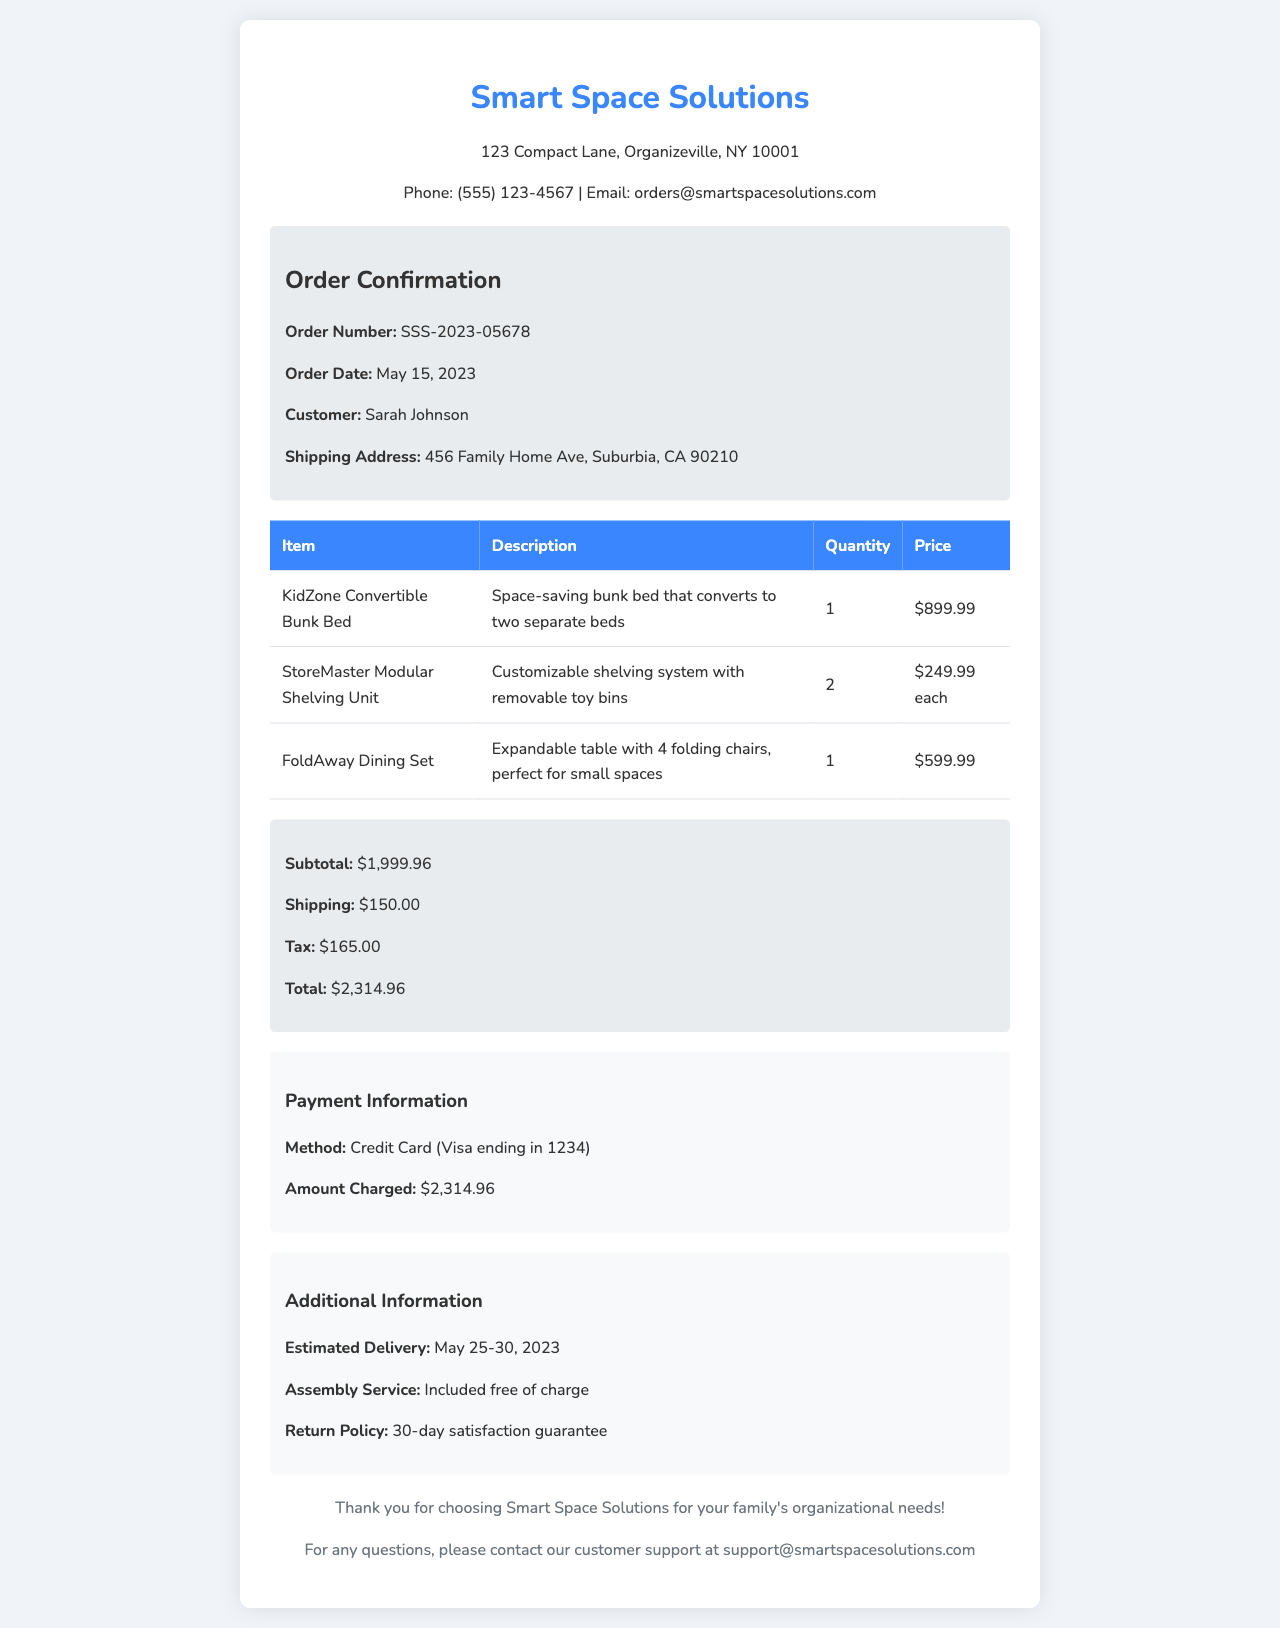What is the order number? The order number is mentioned in the order confirmation section of the document, which is SSS-2023-05678.
Answer: SSS-2023-05678 Who is the customer? The customer's name is listed in the order confirmation section as Sarah Johnson.
Answer: Sarah Johnson What is the total amount charged? The total amount charged is specified in the payment information section, which is $2,314.96.
Answer: $2,314.96 What item is the "KidZone Convertible Bunk Bed"? This item is described as a space-saving bunk bed that converts to two separate beds.
Answer: Space-saving bunk bed that converts to two separate beds How many StoreMaster Modular Shelving Units were ordered? The quantity of StoreMaster Modular Shelving Units is provided in the order details, which is 2.
Answer: 2 What is the estimated delivery date? The estimated delivery date is included in the additional information, which ranges from May 25-30, 2023.
Answer: May 25-30, 2023 Is assembly service included? The details specify that assembly service is included free of charge.
Answer: Included free of charge What is the shipping cost? The shipping cost can be found in the totals section, which is $150.00.
Answer: $150.00 